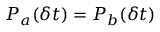<formula> <loc_0><loc_0><loc_500><loc_500>P _ { a } ( \delta t ) = P _ { b } ( \delta t )</formula> 